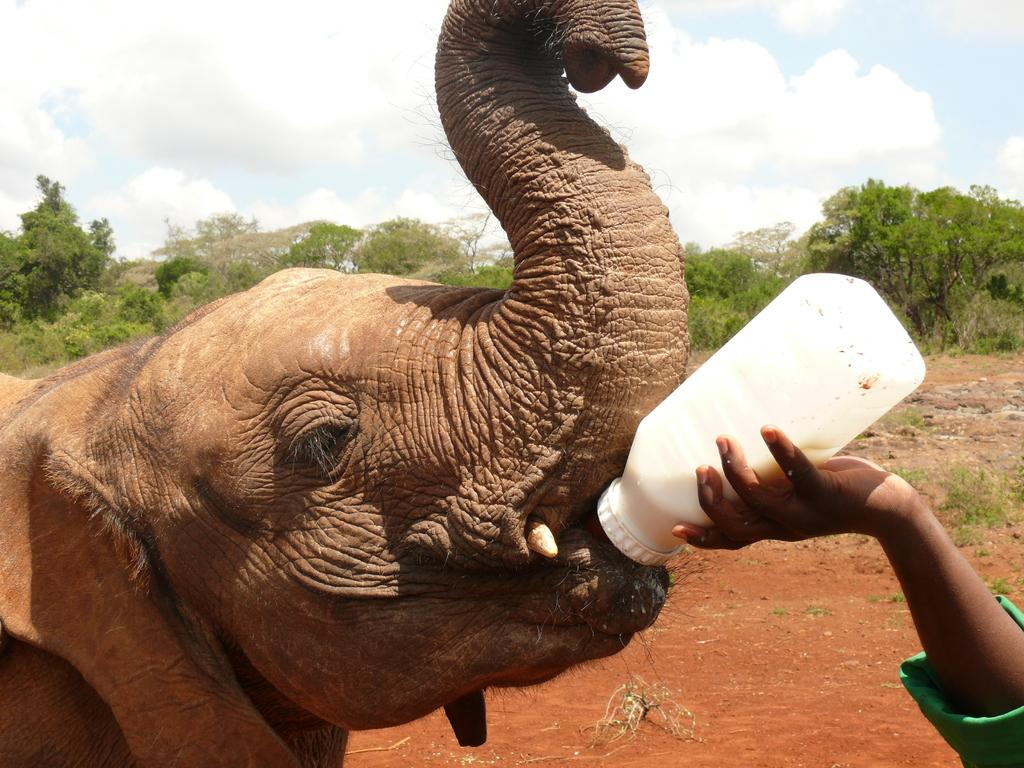Who is present in the image? There is a person in the image. What is the person holding in the image? The person is holding a bottle of milk. What is the person doing with the milk? The person is feeding an elephant. What can be seen behind the elephant? There are trees behind the elephant. What is visible in the sky at the top of the image? There are clouds visible in the sky. How many toes can be seen on the elephant's foot in the image? There are no visible toes on the elephant's foot in the image, as the elephant is not shown in enough detail to see individual toes. 